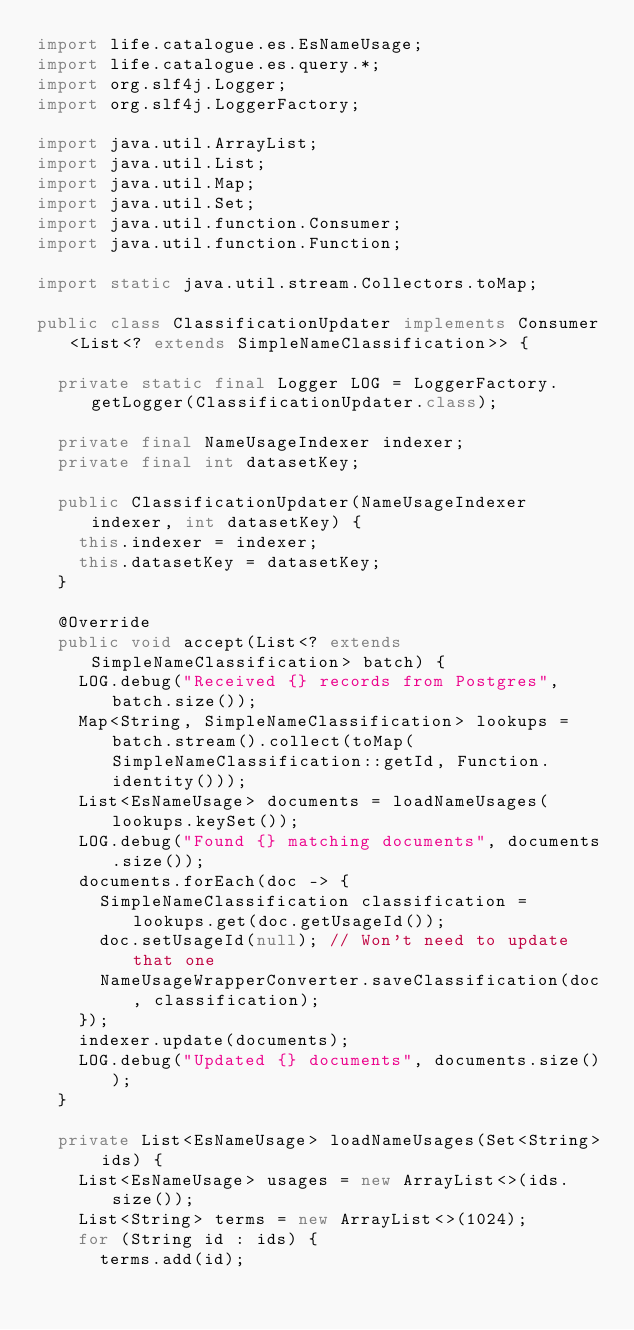<code> <loc_0><loc_0><loc_500><loc_500><_Java_>import life.catalogue.es.EsNameUsage;
import life.catalogue.es.query.*;
import org.slf4j.Logger;
import org.slf4j.LoggerFactory;

import java.util.ArrayList;
import java.util.List;
import java.util.Map;
import java.util.Set;
import java.util.function.Consumer;
import java.util.function.Function;

import static java.util.stream.Collectors.toMap;

public class ClassificationUpdater implements Consumer<List<? extends SimpleNameClassification>> {

  private static final Logger LOG = LoggerFactory.getLogger(ClassificationUpdater.class);

  private final NameUsageIndexer indexer;
  private final int datasetKey;

  public ClassificationUpdater(NameUsageIndexer indexer, int datasetKey) {
    this.indexer = indexer;
    this.datasetKey = datasetKey;
  }

  @Override
  public void accept(List<? extends SimpleNameClassification> batch) {
    LOG.debug("Received {} records from Postgres", batch.size());
    Map<String, SimpleNameClassification> lookups = batch.stream().collect(toMap(SimpleNameClassification::getId, Function.identity()));
    List<EsNameUsage> documents = loadNameUsages(lookups.keySet());
    LOG.debug("Found {} matching documents", documents.size());
    documents.forEach(doc -> {
      SimpleNameClassification classification = lookups.get(doc.getUsageId());
      doc.setUsageId(null); // Won't need to update that one
      NameUsageWrapperConverter.saveClassification(doc, classification);
    });
    indexer.update(documents);
    LOG.debug("Updated {} documents", documents.size());
  }

  private List<EsNameUsage> loadNameUsages(Set<String> ids) {
    List<EsNameUsage> usages = new ArrayList<>(ids.size());
    List<String> terms = new ArrayList<>(1024);
    for (String id : ids) {
      terms.add(id);</code> 